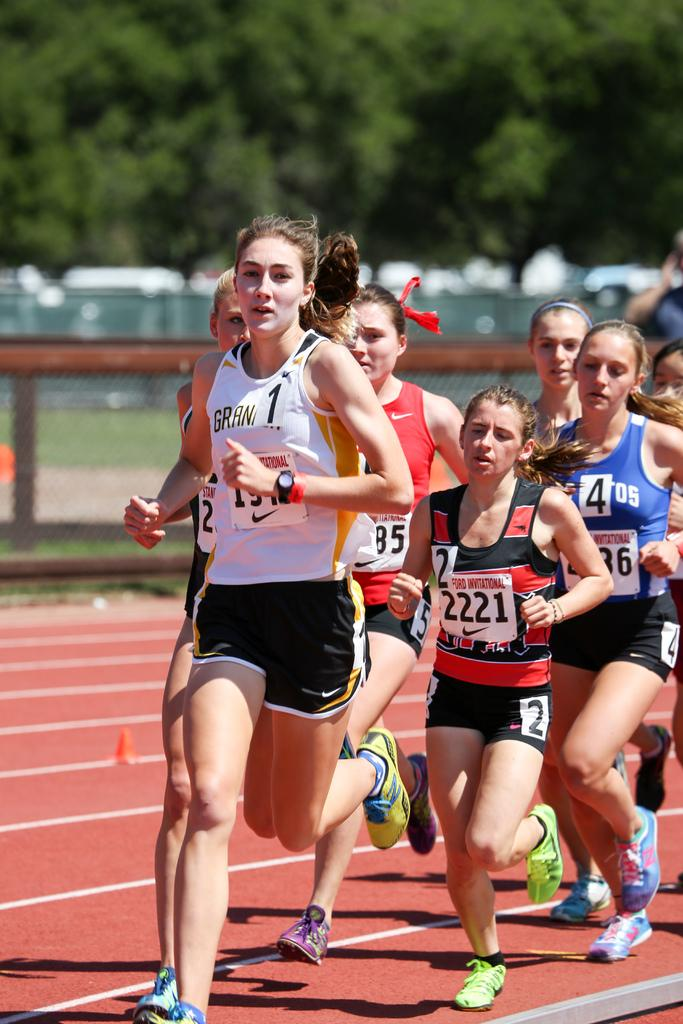<image>
Describe the image concisely. a girl running a track with the number 1 on 